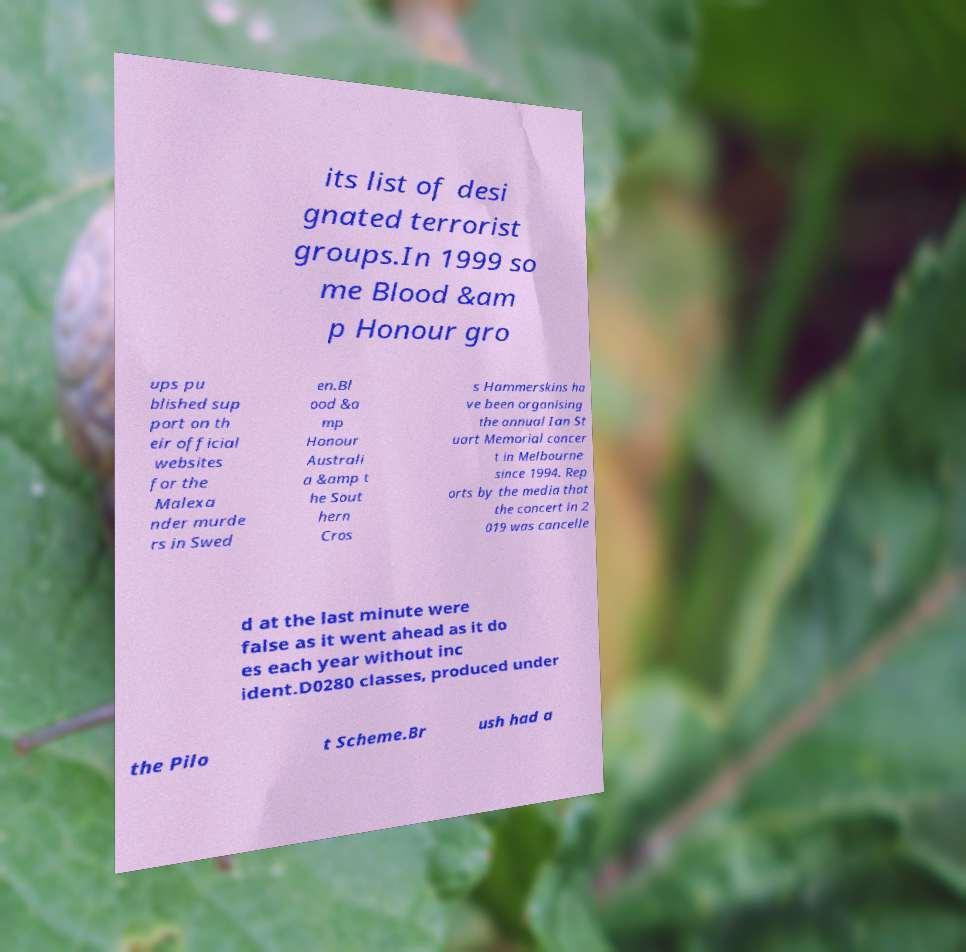For documentation purposes, I need the text within this image transcribed. Could you provide that? its list of desi gnated terrorist groups.In 1999 so me Blood &am p Honour gro ups pu blished sup port on th eir official websites for the Malexa nder murde rs in Swed en.Bl ood &a mp Honour Australi a &amp t he Sout hern Cros s Hammerskins ha ve been organising the annual Ian St uart Memorial concer t in Melbourne since 1994. Rep orts by the media that the concert in 2 019 was cancelle d at the last minute were false as it went ahead as it do es each year without inc ident.D0280 classes, produced under the Pilo t Scheme.Br ush had a 